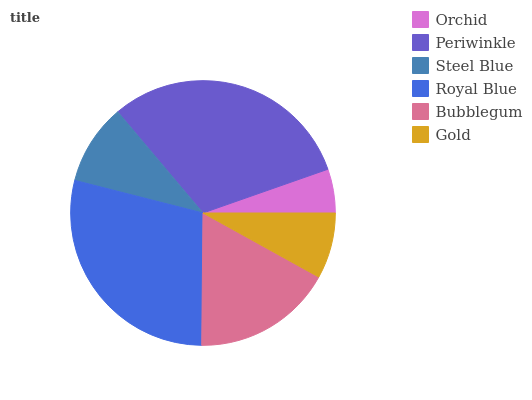Is Orchid the minimum?
Answer yes or no. Yes. Is Periwinkle the maximum?
Answer yes or no. Yes. Is Steel Blue the minimum?
Answer yes or no. No. Is Steel Blue the maximum?
Answer yes or no. No. Is Periwinkle greater than Steel Blue?
Answer yes or no. Yes. Is Steel Blue less than Periwinkle?
Answer yes or no. Yes. Is Steel Blue greater than Periwinkle?
Answer yes or no. No. Is Periwinkle less than Steel Blue?
Answer yes or no. No. Is Bubblegum the high median?
Answer yes or no. Yes. Is Steel Blue the low median?
Answer yes or no. Yes. Is Royal Blue the high median?
Answer yes or no. No. Is Gold the low median?
Answer yes or no. No. 